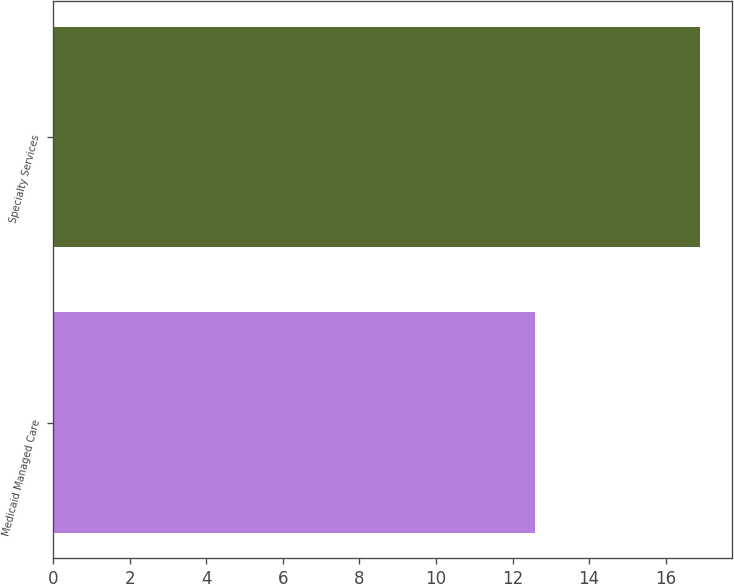Convert chart. <chart><loc_0><loc_0><loc_500><loc_500><bar_chart><fcel>Medicaid Managed Care<fcel>Specialty Services<nl><fcel>12.6<fcel>16.9<nl></chart> 